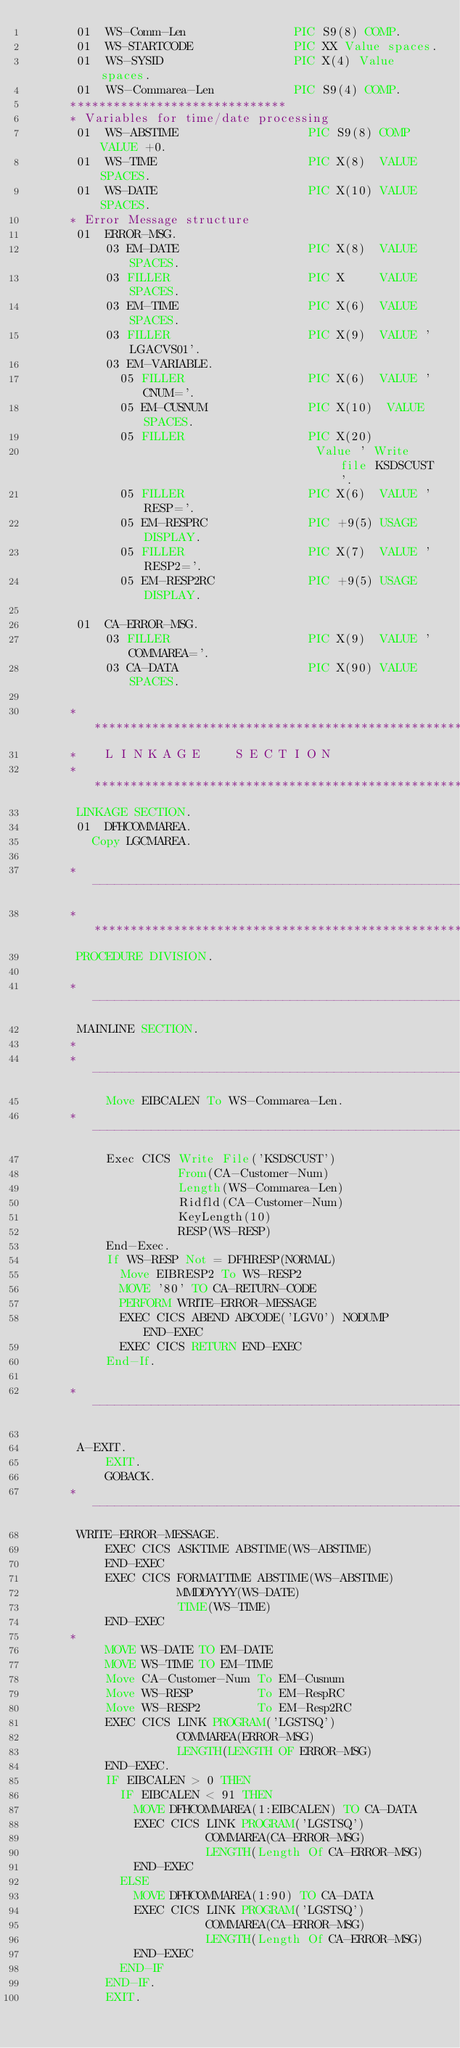<code> <loc_0><loc_0><loc_500><loc_500><_COBOL_>       01  WS-Comm-Len               PIC S9(8) COMP.
       01  WS-STARTCODE              PIC XX Value spaces.
       01  WS-SYSID                  PIC X(4) Value spaces.
       01  WS-Commarea-Len           PIC S9(4) COMP.
      ******************************
      * Variables for time/date processing
       01  WS-ABSTIME                  PIC S9(8) COMP VALUE +0.
       01  WS-TIME                     PIC X(8)  VALUE SPACES.
       01  WS-DATE                     PIC X(10) VALUE SPACES.
      * Error Message structure
       01  ERROR-MSG.
           03 EM-DATE                  PIC X(8)  VALUE SPACES.
           03 FILLER                   PIC X     VALUE SPACES.
           03 EM-TIME                  PIC X(6)  VALUE SPACES.
           03 FILLER                   PIC X(9)  VALUE ' LGACVS01'.
           03 EM-VARIABLE.
             05 FILLER                 PIC X(6)  VALUE ' CNUM='.
             05 EM-CUSNUM              PIC X(10)  VALUE SPACES.
             05 FILLER                 PIC X(20)
                                        Value ' Write file KSDSCUST'.
             05 FILLER                 PIC X(6)  VALUE ' RESP='.
             05 EM-RESPRC              PIC +9(5) USAGE DISPLAY.
             05 FILLER                 PIC X(7)  VALUE ' RESP2='.
             05 EM-RESP2RC             PIC +9(5) USAGE DISPLAY.

       01  CA-ERROR-MSG.
           03 FILLER                   PIC X(9)  VALUE 'COMMAREA='.
           03 CA-DATA                  PIC X(90) VALUE SPACES.

      *****************************************************************
      *    L I N K A G E     S E C T I O N
      *****************************************************************
       LINKAGE SECTION.
       01  DFHCOMMAREA.
         Copy LGCMAREA.

      *----------------------------------------------------------------*
      *****************************************************************
       PROCEDURE DIVISION.

      *---------------------------------------------------------------*
       MAINLINE SECTION.
      *
      *---------------------------------------------------------------*
           Move EIBCALEN To WS-Commarea-Len.
      *---------------------------------------------------------------*
           Exec CICS Write File('KSDSCUST')
                     From(CA-Customer-Num)
                     Length(WS-Commarea-Len)
                     Ridfld(CA-Customer-Num)
                     KeyLength(10)
                     RESP(WS-RESP)
           End-Exec.
           If WS-RESP Not = DFHRESP(NORMAL)
             Move EIBRESP2 To WS-RESP2
             MOVE '80' TO CA-RETURN-CODE
             PERFORM WRITE-ERROR-MESSAGE
             EXEC CICS ABEND ABCODE('LGV0') NODUMP END-EXEC
             EXEC CICS RETURN END-EXEC
           End-If.

      *---------------------------------------------------------------*

       A-EXIT.
           EXIT.
           GOBACK.
      *---------------------------------------------------------------*
       WRITE-ERROR-MESSAGE.
           EXEC CICS ASKTIME ABSTIME(WS-ABSTIME)
           END-EXEC
           EXEC CICS FORMATTIME ABSTIME(WS-ABSTIME)
                     MMDDYYYY(WS-DATE)
                     TIME(WS-TIME)
           END-EXEC
      *
           MOVE WS-DATE TO EM-DATE
           MOVE WS-TIME TO EM-TIME
           Move CA-Customer-Num To EM-Cusnum
           Move WS-RESP         To EM-RespRC
           Move WS-RESP2        To EM-Resp2RC
           EXEC CICS LINK PROGRAM('LGSTSQ')
                     COMMAREA(ERROR-MSG)
                     LENGTH(LENGTH OF ERROR-MSG)
           END-EXEC.
           IF EIBCALEN > 0 THEN
             IF EIBCALEN < 91 THEN
               MOVE DFHCOMMAREA(1:EIBCALEN) TO CA-DATA
               EXEC CICS LINK PROGRAM('LGSTSQ')
                         COMMAREA(CA-ERROR-MSG)
                         LENGTH(Length Of CA-ERROR-MSG)
               END-EXEC
             ELSE
               MOVE DFHCOMMAREA(1:90) TO CA-DATA
               EXEC CICS LINK PROGRAM('LGSTSQ')
                         COMMAREA(CA-ERROR-MSG)
                         LENGTH(Length Of CA-ERROR-MSG)
               END-EXEC
             END-IF
           END-IF.
           EXIT.
</code> 